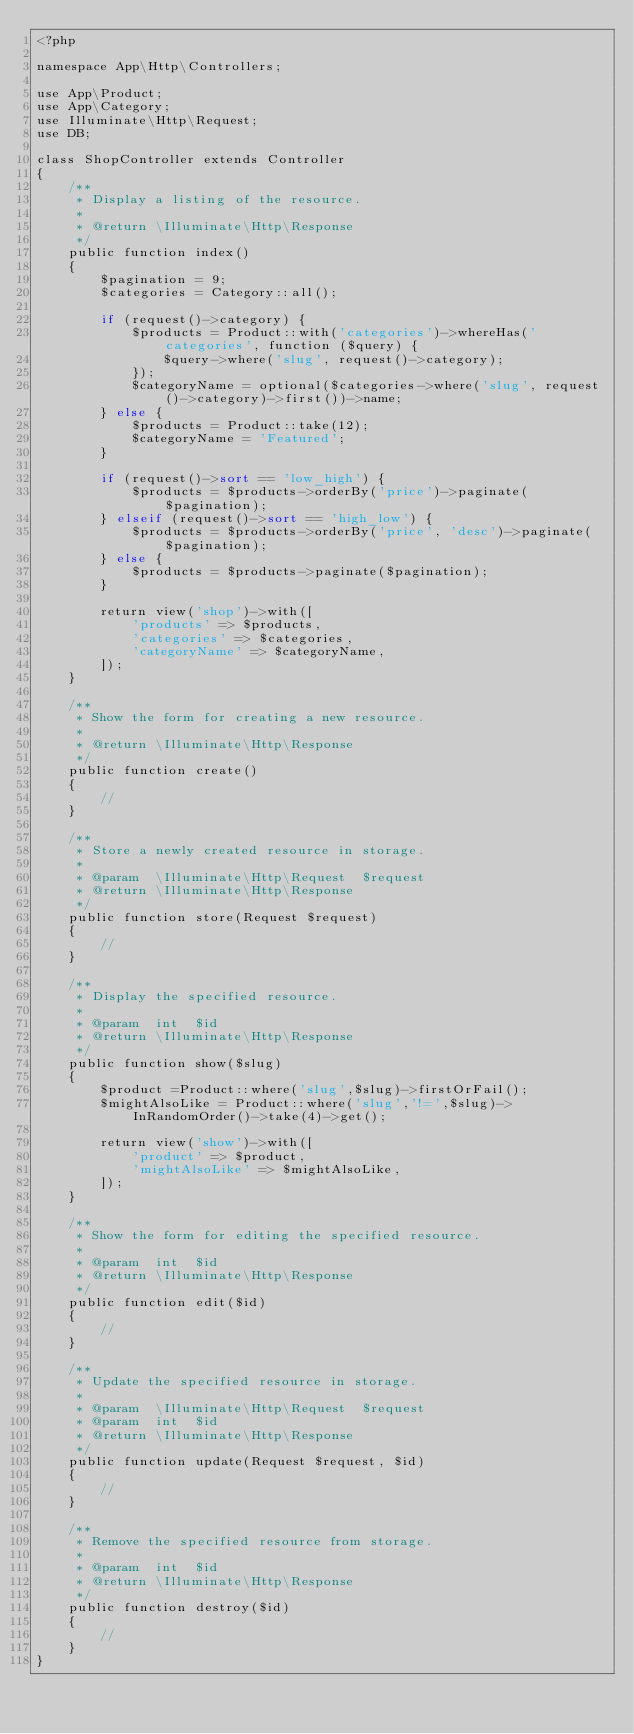Convert code to text. <code><loc_0><loc_0><loc_500><loc_500><_PHP_><?php

namespace App\Http\Controllers;

use App\Product;
use App\Category;
use Illuminate\Http\Request;
use DB;

class ShopController extends Controller
{
    /**
     * Display a listing of the resource.
     *
     * @return \Illuminate\Http\Response
     */
    public function index()
    {
        $pagination = 9;
        $categories = Category::all();

        if (request()->category) {
            $products = Product::with('categories')->whereHas('categories', function ($query) {
                $query->where('slug', request()->category);
            });
            $categoryName = optional($categories->where('slug', request()->category)->first())->name;
        } else {
            $products = Product::take(12);
            $categoryName = 'Featured';
        }

        if (request()->sort == 'low_high') {
            $products = $products->orderBy('price')->paginate($pagination);
        } elseif (request()->sort == 'high_low') {
            $products = $products->orderBy('price', 'desc')->paginate($pagination);
        } else {
            $products = $products->paginate($pagination);
        }

        return view('shop')->with([
            'products' => $products,
            'categories' => $categories,
            'categoryName' => $categoryName,
        ]);
    }

    /**
     * Show the form for creating a new resource.
     *
     * @return \Illuminate\Http\Response
     */
    public function create()
    {
        //
    }

    /**
     * Store a newly created resource in storage.
     *
     * @param  \Illuminate\Http\Request  $request
     * @return \Illuminate\Http\Response
     */
    public function store(Request $request)
    {
        //
    }

    /**
     * Display the specified resource.
     *
     * @param  int  $id
     * @return \Illuminate\Http\Response
     */
    public function show($slug)
    {
        $product =Product::where('slug',$slug)->firstOrFail();
        $mightAlsoLike = Product::where('slug','!=',$slug)->InRandomOrder()->take(4)->get();

        return view('show')->with([
            'product' => $product,
            'mightAlsoLike' => $mightAlsoLike, 
        ]);
    }

    /**
     * Show the form for editing the specified resource.
     *
     * @param  int  $id
     * @return \Illuminate\Http\Response
     */
    public function edit($id)
    {
        //
    }

    /**
     * Update the specified resource in storage.
     *
     * @param  \Illuminate\Http\Request  $request
     * @param  int  $id
     * @return \Illuminate\Http\Response
     */
    public function update(Request $request, $id)
    {
        //
    }

    /**
     * Remove the specified resource from storage.
     *
     * @param  int  $id
     * @return \Illuminate\Http\Response
     */
    public function destroy($id)
    {
        //
    }
}
</code> 